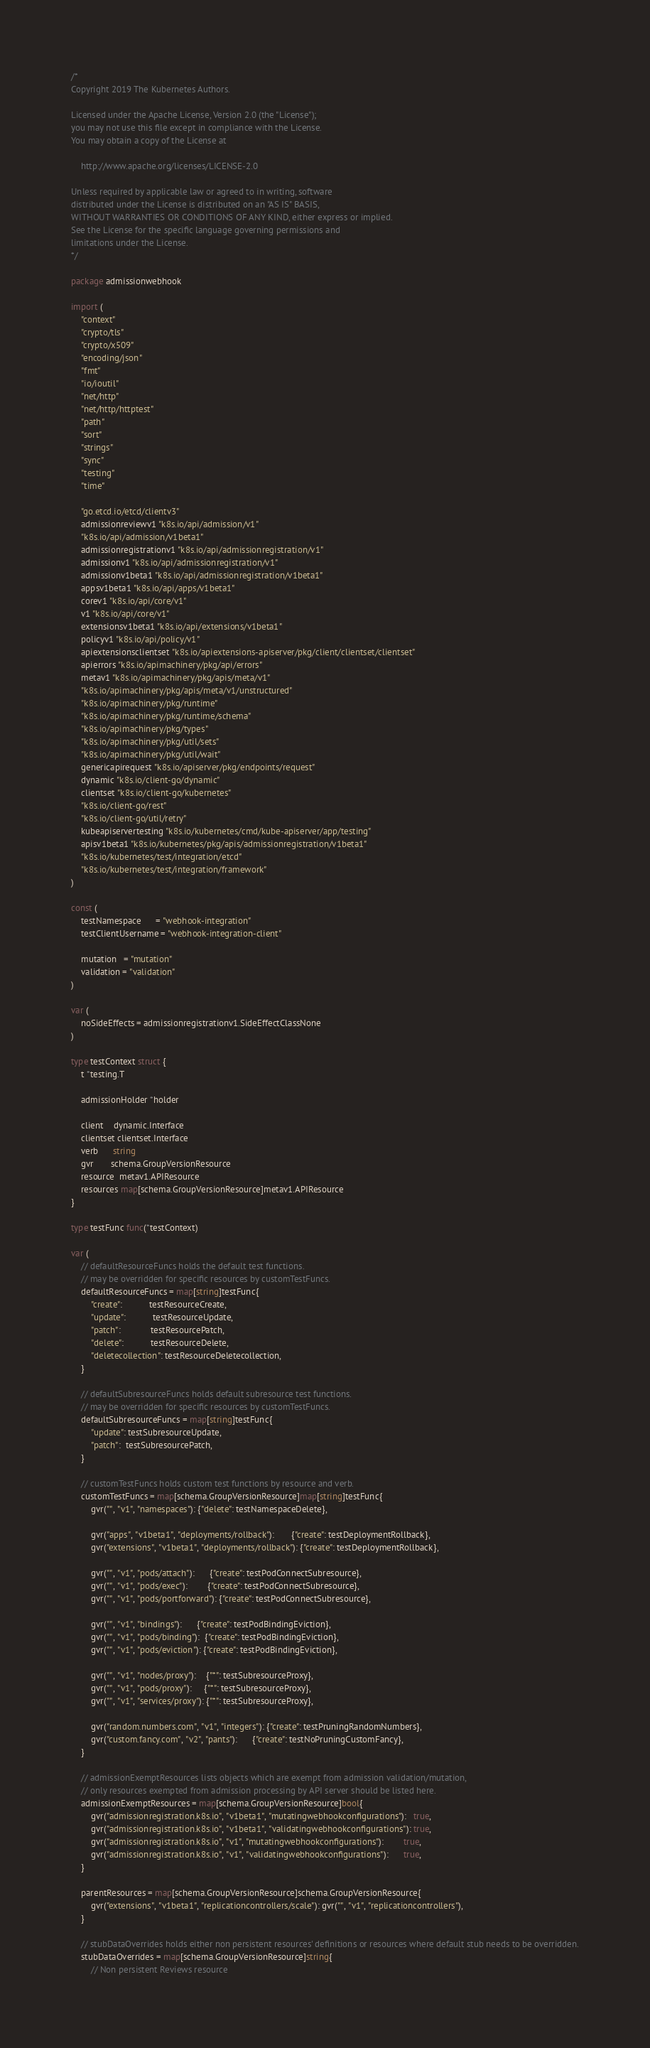Convert code to text. <code><loc_0><loc_0><loc_500><loc_500><_Go_>/*
Copyright 2019 The Kubernetes Authors.

Licensed under the Apache License, Version 2.0 (the "License");
you may not use this file except in compliance with the License.
You may obtain a copy of the License at

    http://www.apache.org/licenses/LICENSE-2.0

Unless required by applicable law or agreed to in writing, software
distributed under the License is distributed on an "AS IS" BASIS,
WITHOUT WARRANTIES OR CONDITIONS OF ANY KIND, either express or implied.
See the License for the specific language governing permissions and
limitations under the License.
*/

package admissionwebhook

import (
	"context"
	"crypto/tls"
	"crypto/x509"
	"encoding/json"
	"fmt"
	"io/ioutil"
	"net/http"
	"net/http/httptest"
	"path"
	"sort"
	"strings"
	"sync"
	"testing"
	"time"

	"go.etcd.io/etcd/clientv3"
	admissionreviewv1 "k8s.io/api/admission/v1"
	"k8s.io/api/admission/v1beta1"
	admissionregistrationv1 "k8s.io/api/admissionregistration/v1"
	admissionv1 "k8s.io/api/admissionregistration/v1"
	admissionv1beta1 "k8s.io/api/admissionregistration/v1beta1"
	appsv1beta1 "k8s.io/api/apps/v1beta1"
	corev1 "k8s.io/api/core/v1"
	v1 "k8s.io/api/core/v1"
	extensionsv1beta1 "k8s.io/api/extensions/v1beta1"
	policyv1 "k8s.io/api/policy/v1"
	apiextensionsclientset "k8s.io/apiextensions-apiserver/pkg/client/clientset/clientset"
	apierrors "k8s.io/apimachinery/pkg/api/errors"
	metav1 "k8s.io/apimachinery/pkg/apis/meta/v1"
	"k8s.io/apimachinery/pkg/apis/meta/v1/unstructured"
	"k8s.io/apimachinery/pkg/runtime"
	"k8s.io/apimachinery/pkg/runtime/schema"
	"k8s.io/apimachinery/pkg/types"
	"k8s.io/apimachinery/pkg/util/sets"
	"k8s.io/apimachinery/pkg/util/wait"
	genericapirequest "k8s.io/apiserver/pkg/endpoints/request"
	dynamic "k8s.io/client-go/dynamic"
	clientset "k8s.io/client-go/kubernetes"
	"k8s.io/client-go/rest"
	"k8s.io/client-go/util/retry"
	kubeapiservertesting "k8s.io/kubernetes/cmd/kube-apiserver/app/testing"
	apisv1beta1 "k8s.io/kubernetes/pkg/apis/admissionregistration/v1beta1"
	"k8s.io/kubernetes/test/integration/etcd"
	"k8s.io/kubernetes/test/integration/framework"
)

const (
	testNamespace      = "webhook-integration"
	testClientUsername = "webhook-integration-client"

	mutation   = "mutation"
	validation = "validation"
)

var (
	noSideEffects = admissionregistrationv1.SideEffectClassNone
)

type testContext struct {
	t *testing.T

	admissionHolder *holder

	client    dynamic.Interface
	clientset clientset.Interface
	verb      string
	gvr       schema.GroupVersionResource
	resource  metav1.APIResource
	resources map[schema.GroupVersionResource]metav1.APIResource
}

type testFunc func(*testContext)

var (
	// defaultResourceFuncs holds the default test functions.
	// may be overridden for specific resources by customTestFuncs.
	defaultResourceFuncs = map[string]testFunc{
		"create":           testResourceCreate,
		"update":           testResourceUpdate,
		"patch":            testResourcePatch,
		"delete":           testResourceDelete,
		"deletecollection": testResourceDeletecollection,
	}

	// defaultSubresourceFuncs holds default subresource test functions.
	// may be overridden for specific resources by customTestFuncs.
	defaultSubresourceFuncs = map[string]testFunc{
		"update": testSubresourceUpdate,
		"patch":  testSubresourcePatch,
	}

	// customTestFuncs holds custom test functions by resource and verb.
	customTestFuncs = map[schema.GroupVersionResource]map[string]testFunc{
		gvr("", "v1", "namespaces"): {"delete": testNamespaceDelete},

		gvr("apps", "v1beta1", "deployments/rollback"):       {"create": testDeploymentRollback},
		gvr("extensions", "v1beta1", "deployments/rollback"): {"create": testDeploymentRollback},

		gvr("", "v1", "pods/attach"):      {"create": testPodConnectSubresource},
		gvr("", "v1", "pods/exec"):        {"create": testPodConnectSubresource},
		gvr("", "v1", "pods/portforward"): {"create": testPodConnectSubresource},

		gvr("", "v1", "bindings"):      {"create": testPodBindingEviction},
		gvr("", "v1", "pods/binding"):  {"create": testPodBindingEviction},
		gvr("", "v1", "pods/eviction"): {"create": testPodBindingEviction},

		gvr("", "v1", "nodes/proxy"):    {"*": testSubresourceProxy},
		gvr("", "v1", "pods/proxy"):     {"*": testSubresourceProxy},
		gvr("", "v1", "services/proxy"): {"*": testSubresourceProxy},

		gvr("random.numbers.com", "v1", "integers"): {"create": testPruningRandomNumbers},
		gvr("custom.fancy.com", "v2", "pants"):      {"create": testNoPruningCustomFancy},
	}

	// admissionExemptResources lists objects which are exempt from admission validation/mutation,
	// only resources exempted from admission processing by API server should be listed here.
	admissionExemptResources = map[schema.GroupVersionResource]bool{
		gvr("admissionregistration.k8s.io", "v1beta1", "mutatingwebhookconfigurations"):   true,
		gvr("admissionregistration.k8s.io", "v1beta1", "validatingwebhookconfigurations"): true,
		gvr("admissionregistration.k8s.io", "v1", "mutatingwebhookconfigurations"):        true,
		gvr("admissionregistration.k8s.io", "v1", "validatingwebhookconfigurations"):      true,
	}

	parentResources = map[schema.GroupVersionResource]schema.GroupVersionResource{
		gvr("extensions", "v1beta1", "replicationcontrollers/scale"): gvr("", "v1", "replicationcontrollers"),
	}

	// stubDataOverrides holds either non persistent resources' definitions or resources where default stub needs to be overridden.
	stubDataOverrides = map[schema.GroupVersionResource]string{
		// Non persistent Reviews resource</code> 